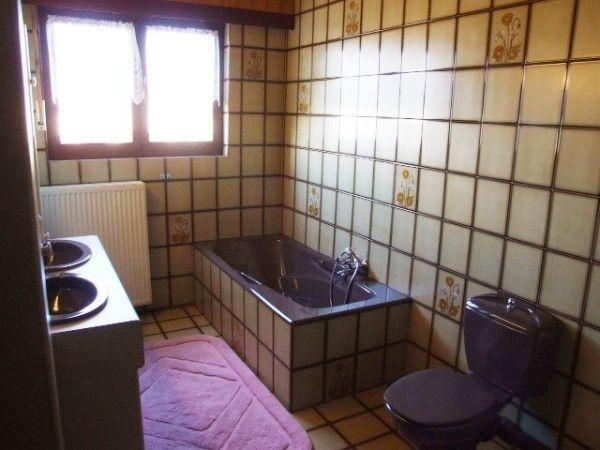What happens in this room? Please explain your reasoning. washing hands. There is a sink with soap next to it. 